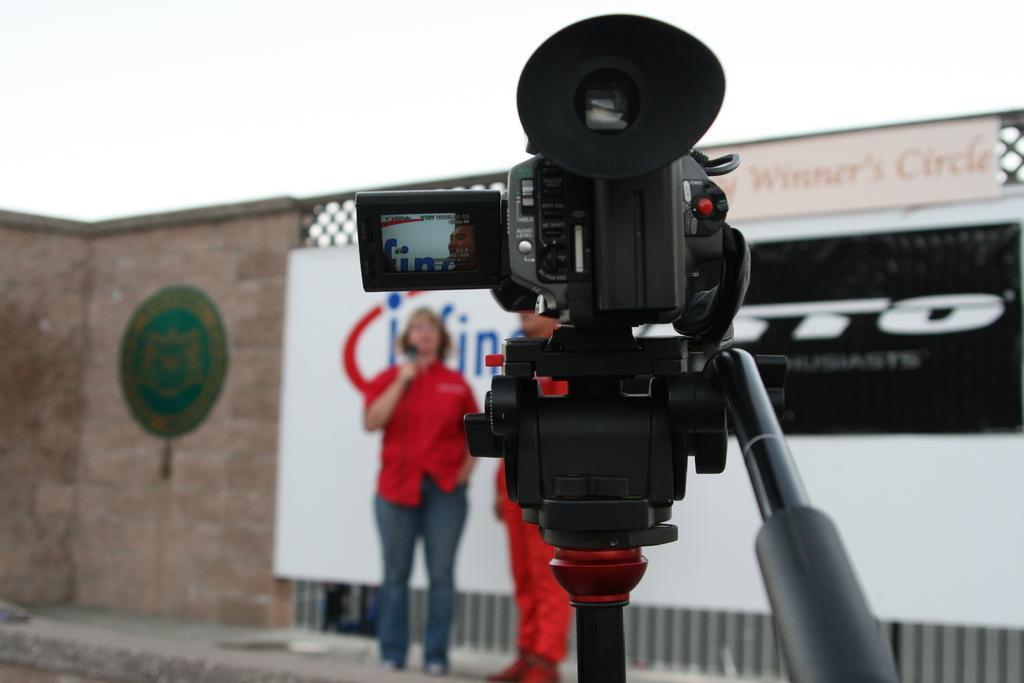How would you summarize this image in a sentence or two? In the center of the image we can see a camera placed on the stand. In the background there are people standing and there is a wall. We can see a board. At the top there is sky. 